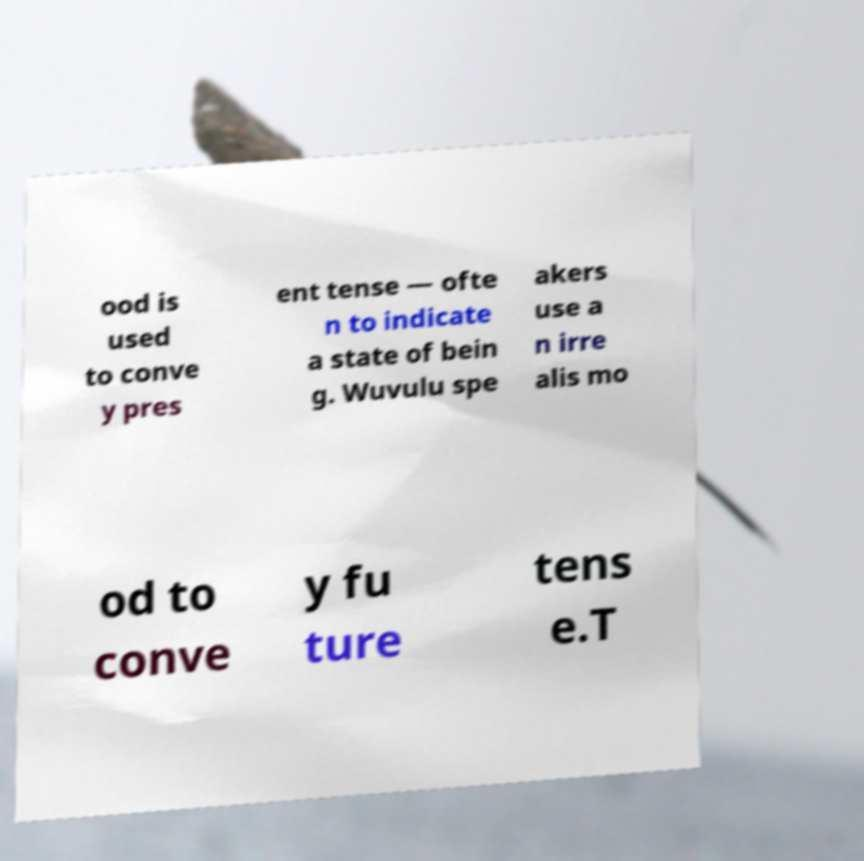Could you assist in decoding the text presented in this image and type it out clearly? ood is used to conve y pres ent tense — ofte n to indicate a state of bein g. Wuvulu spe akers use a n irre alis mo od to conve y fu ture tens e.T 